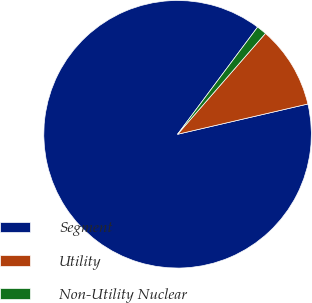Convert chart. <chart><loc_0><loc_0><loc_500><loc_500><pie_chart><fcel>Segment<fcel>Utility<fcel>Non-Utility Nuclear<nl><fcel>88.84%<fcel>9.96%<fcel>1.2%<nl></chart> 